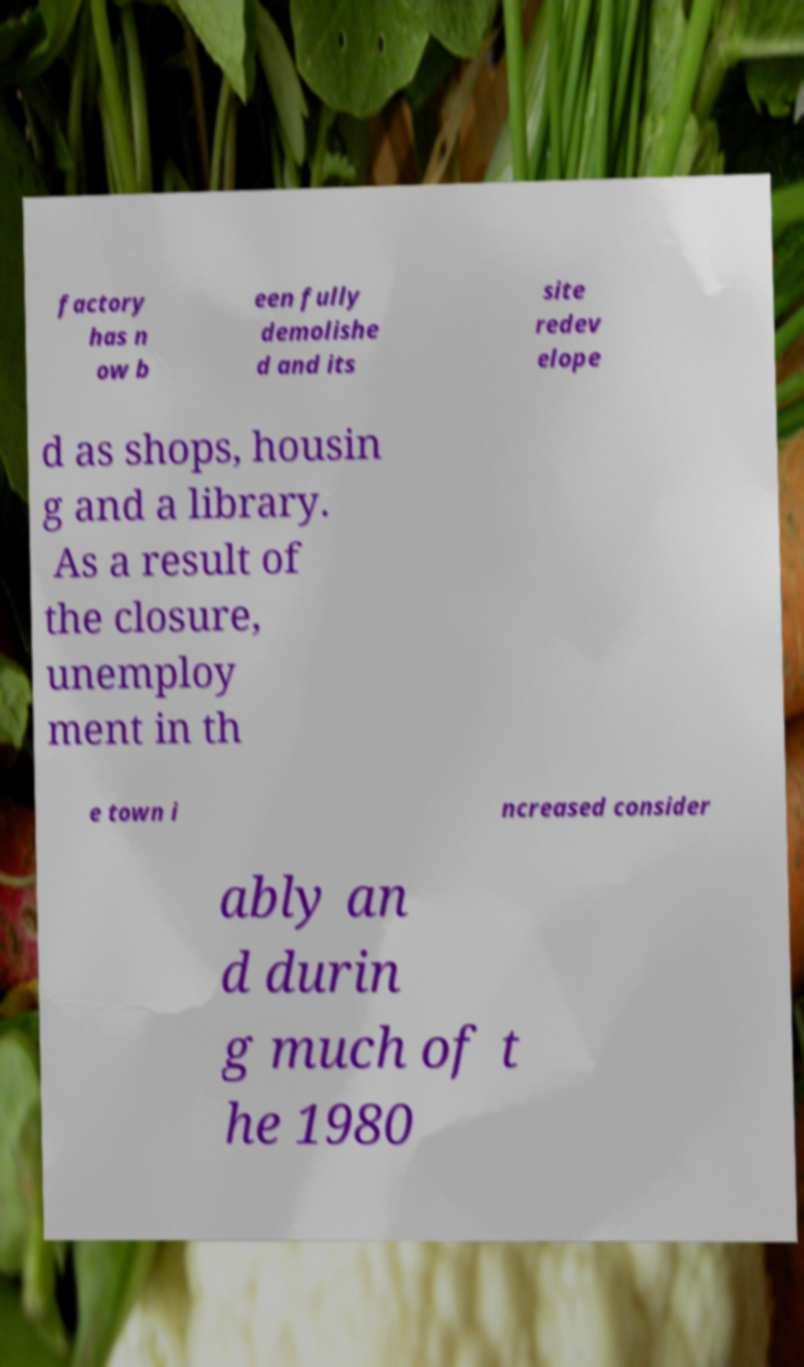There's text embedded in this image that I need extracted. Can you transcribe it verbatim? factory has n ow b een fully demolishe d and its site redev elope d as shops, housin g and a library. As a result of the closure, unemploy ment in th e town i ncreased consider ably an d durin g much of t he 1980 